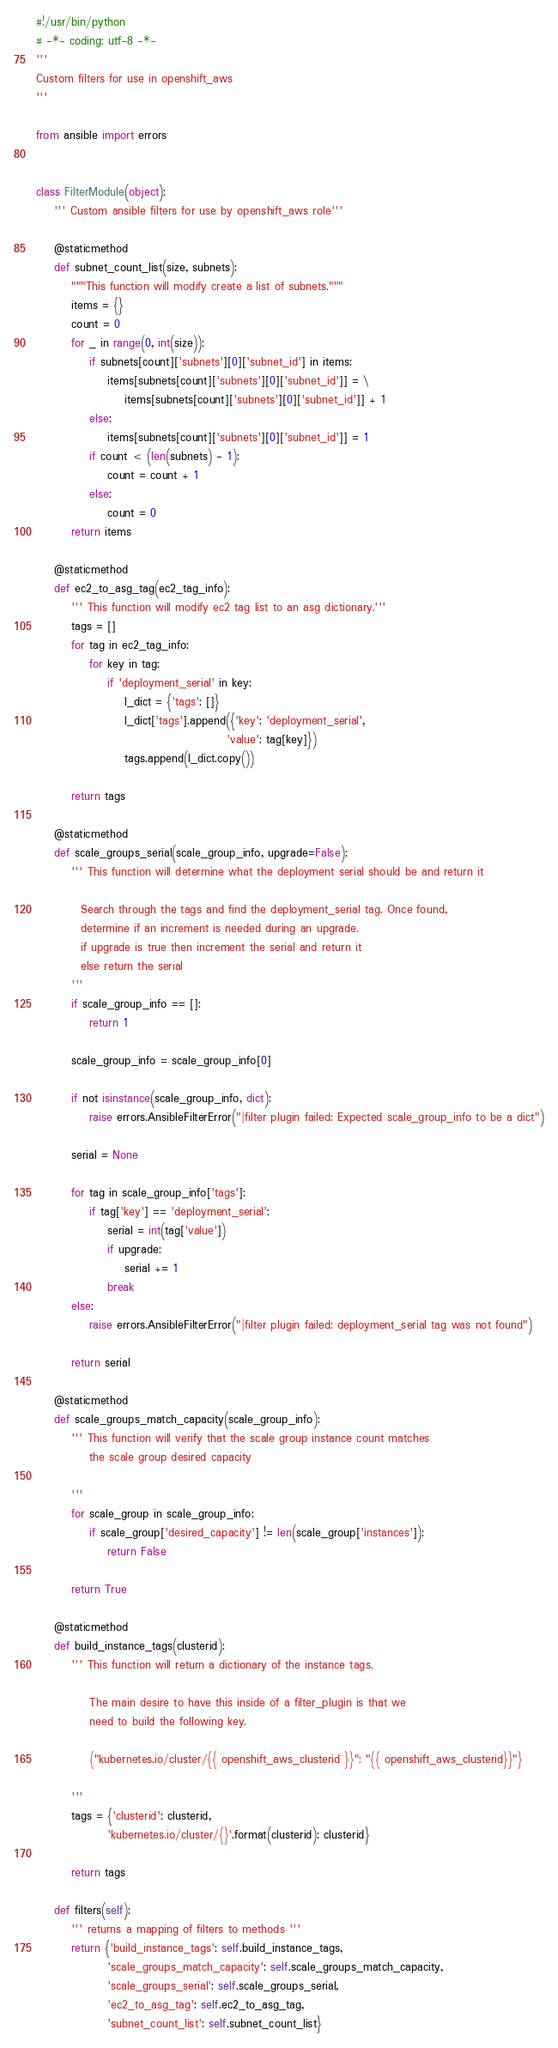<code> <loc_0><loc_0><loc_500><loc_500><_Python_>#!/usr/bin/python
# -*- coding: utf-8 -*-
'''
Custom filters for use in openshift_aws
'''

from ansible import errors


class FilterModule(object):
    ''' Custom ansible filters for use by openshift_aws role'''

    @staticmethod
    def subnet_count_list(size, subnets):
        """This function will modify create a list of subnets."""
        items = {}
        count = 0
        for _ in range(0, int(size)):
            if subnets[count]['subnets'][0]['subnet_id'] in items:
                items[subnets[count]['subnets'][0]['subnet_id']] = \
                    items[subnets[count]['subnets'][0]['subnet_id']] + 1
            else:
                items[subnets[count]['subnets'][0]['subnet_id']] = 1
            if count < (len(subnets) - 1):
                count = count + 1
            else:
                count = 0
        return items

    @staticmethod
    def ec2_to_asg_tag(ec2_tag_info):
        ''' This function will modify ec2 tag list to an asg dictionary.'''
        tags = []
        for tag in ec2_tag_info:
            for key in tag:
                if 'deployment_serial' in key:
                    l_dict = {'tags': []}
                    l_dict['tags'].append({'key': 'deployment_serial',
                                           'value': tag[key]})
                    tags.append(l_dict.copy())

        return tags

    @staticmethod
    def scale_groups_serial(scale_group_info, upgrade=False):
        ''' This function will determine what the deployment serial should be and return it

          Search through the tags and find the deployment_serial tag. Once found,
          determine if an increment is needed during an upgrade.
          if upgrade is true then increment the serial and return it
          else return the serial
        '''
        if scale_group_info == []:
            return 1

        scale_group_info = scale_group_info[0]

        if not isinstance(scale_group_info, dict):
            raise errors.AnsibleFilterError("|filter plugin failed: Expected scale_group_info to be a dict")

        serial = None

        for tag in scale_group_info['tags']:
            if tag['key'] == 'deployment_serial':
                serial = int(tag['value'])
                if upgrade:
                    serial += 1
                break
        else:
            raise errors.AnsibleFilterError("|filter plugin failed: deployment_serial tag was not found")

        return serial

    @staticmethod
    def scale_groups_match_capacity(scale_group_info):
        ''' This function will verify that the scale group instance count matches
            the scale group desired capacity

        '''
        for scale_group in scale_group_info:
            if scale_group['desired_capacity'] != len(scale_group['instances']):
                return False

        return True

    @staticmethod
    def build_instance_tags(clusterid):
        ''' This function will return a dictionary of the instance tags.

            The main desire to have this inside of a filter_plugin is that we
            need to build the following key.

            {"kubernetes.io/cluster/{{ openshift_aws_clusterid }}": "{{ openshift_aws_clusterid}}"}

        '''
        tags = {'clusterid': clusterid,
                'kubernetes.io/cluster/{}'.format(clusterid): clusterid}

        return tags

    def filters(self):
        ''' returns a mapping of filters to methods '''
        return {'build_instance_tags': self.build_instance_tags,
                'scale_groups_match_capacity': self.scale_groups_match_capacity,
                'scale_groups_serial': self.scale_groups_serial,
                'ec2_to_asg_tag': self.ec2_to_asg_tag,
                'subnet_count_list': self.subnet_count_list}
</code> 